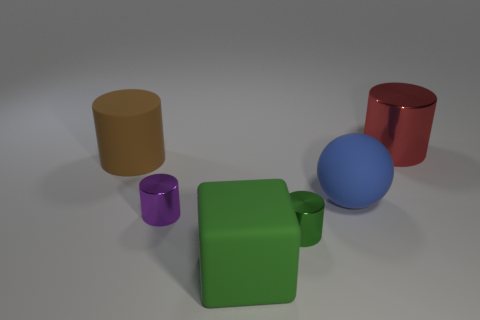Subtract all brown matte cylinders. How many cylinders are left? 3 Subtract all red cylinders. How many cylinders are left? 3 Add 2 big green cubes. How many objects exist? 8 Subtract 1 balls. How many balls are left? 0 Add 5 green rubber things. How many green rubber things exist? 6 Subtract 0 gray blocks. How many objects are left? 6 Subtract all spheres. How many objects are left? 5 Subtract all gray cubes. Subtract all blue cylinders. How many cubes are left? 1 Subtract all brown blocks. How many purple cylinders are left? 1 Subtract all yellow metal balls. Subtract all large brown rubber objects. How many objects are left? 5 